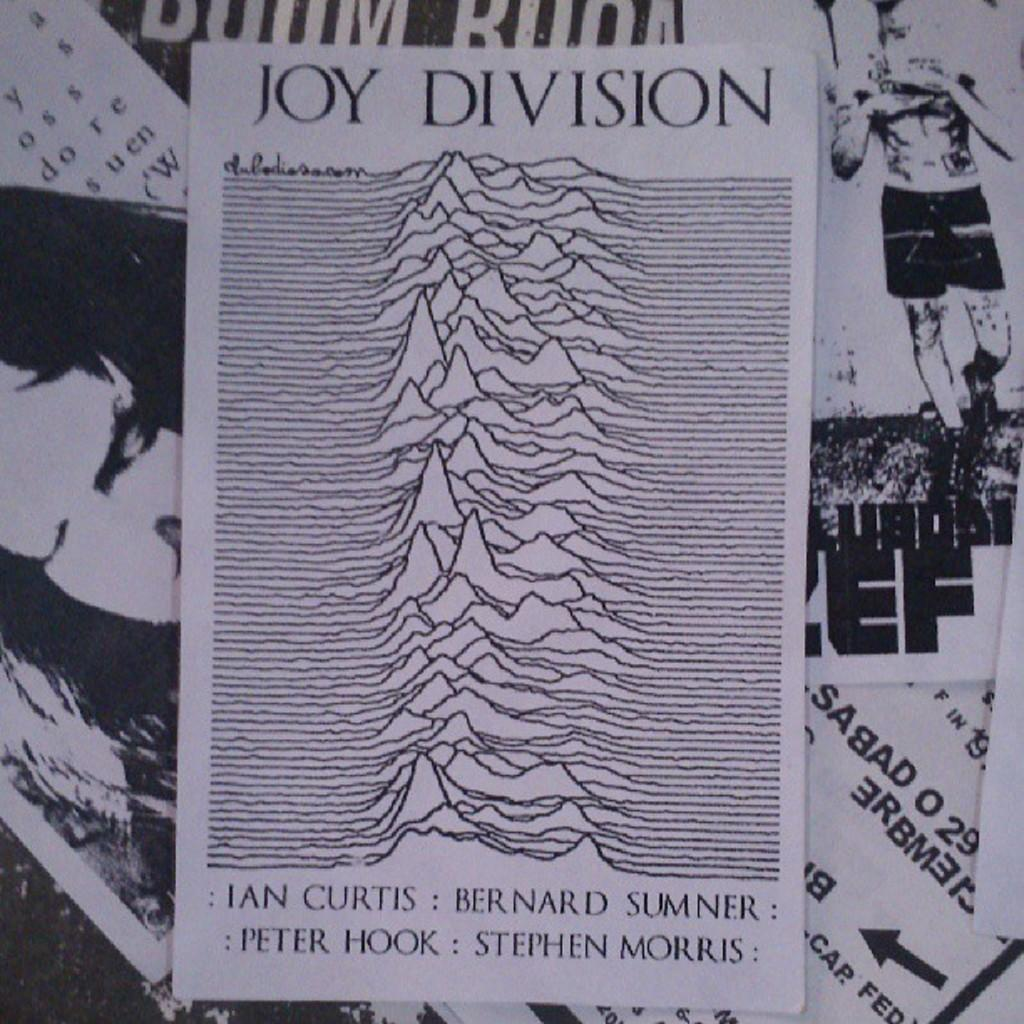<image>
Relay a brief, clear account of the picture shown. Joy Division includes pictures and words on the paper 